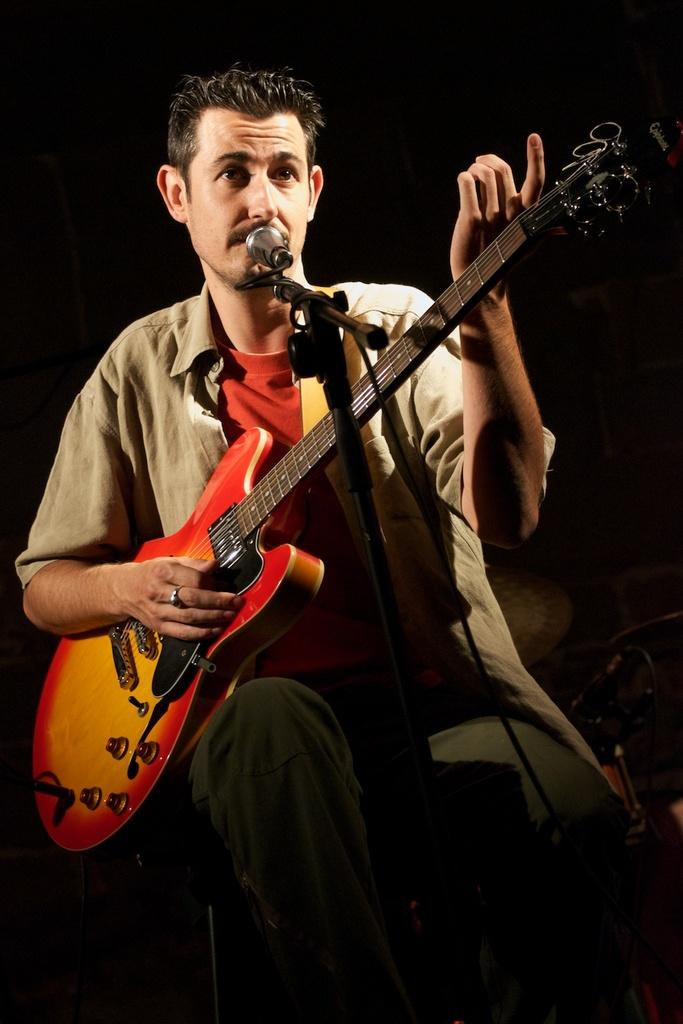What is the man in the image doing? The man is sitting, playing the guitar, and singing on a microphone. What object is the man holding in the image? The man is holding a guitar in the image. What is the lighting condition in the background of the image? The background of the image is dark. How much juice is the man drinking in the image? There is no juice present in the image, so it cannot be determined how much the man might be drinking. 